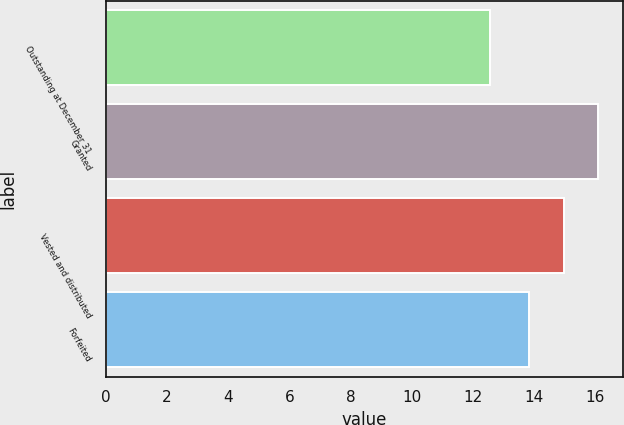Convert chart. <chart><loc_0><loc_0><loc_500><loc_500><bar_chart><fcel>Outstanding at December 31<fcel>Granted<fcel>Vested and distributed<fcel>Forfeited<nl><fcel>12.55<fcel>16.1<fcel>14.97<fcel>13.84<nl></chart> 